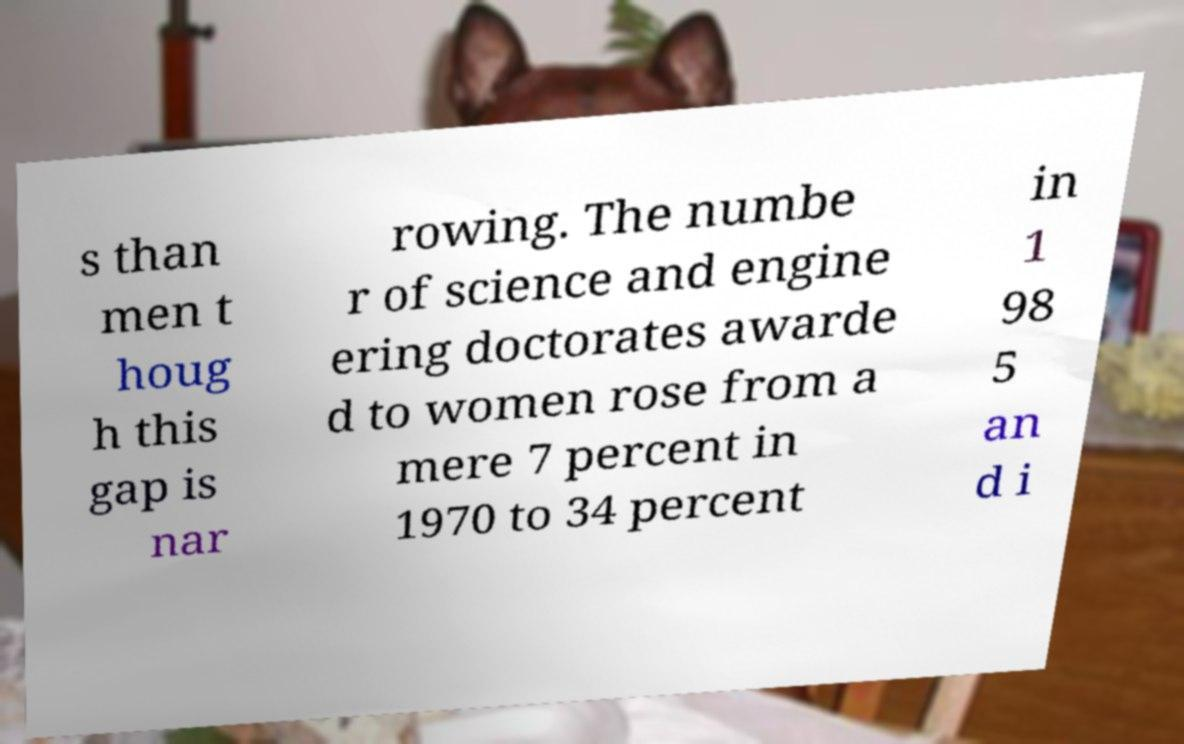I need the written content from this picture converted into text. Can you do that? s than men t houg h this gap is nar rowing. The numbe r of science and engine ering doctorates awarde d to women rose from a mere 7 percent in 1970 to 34 percent in 1 98 5 an d i 